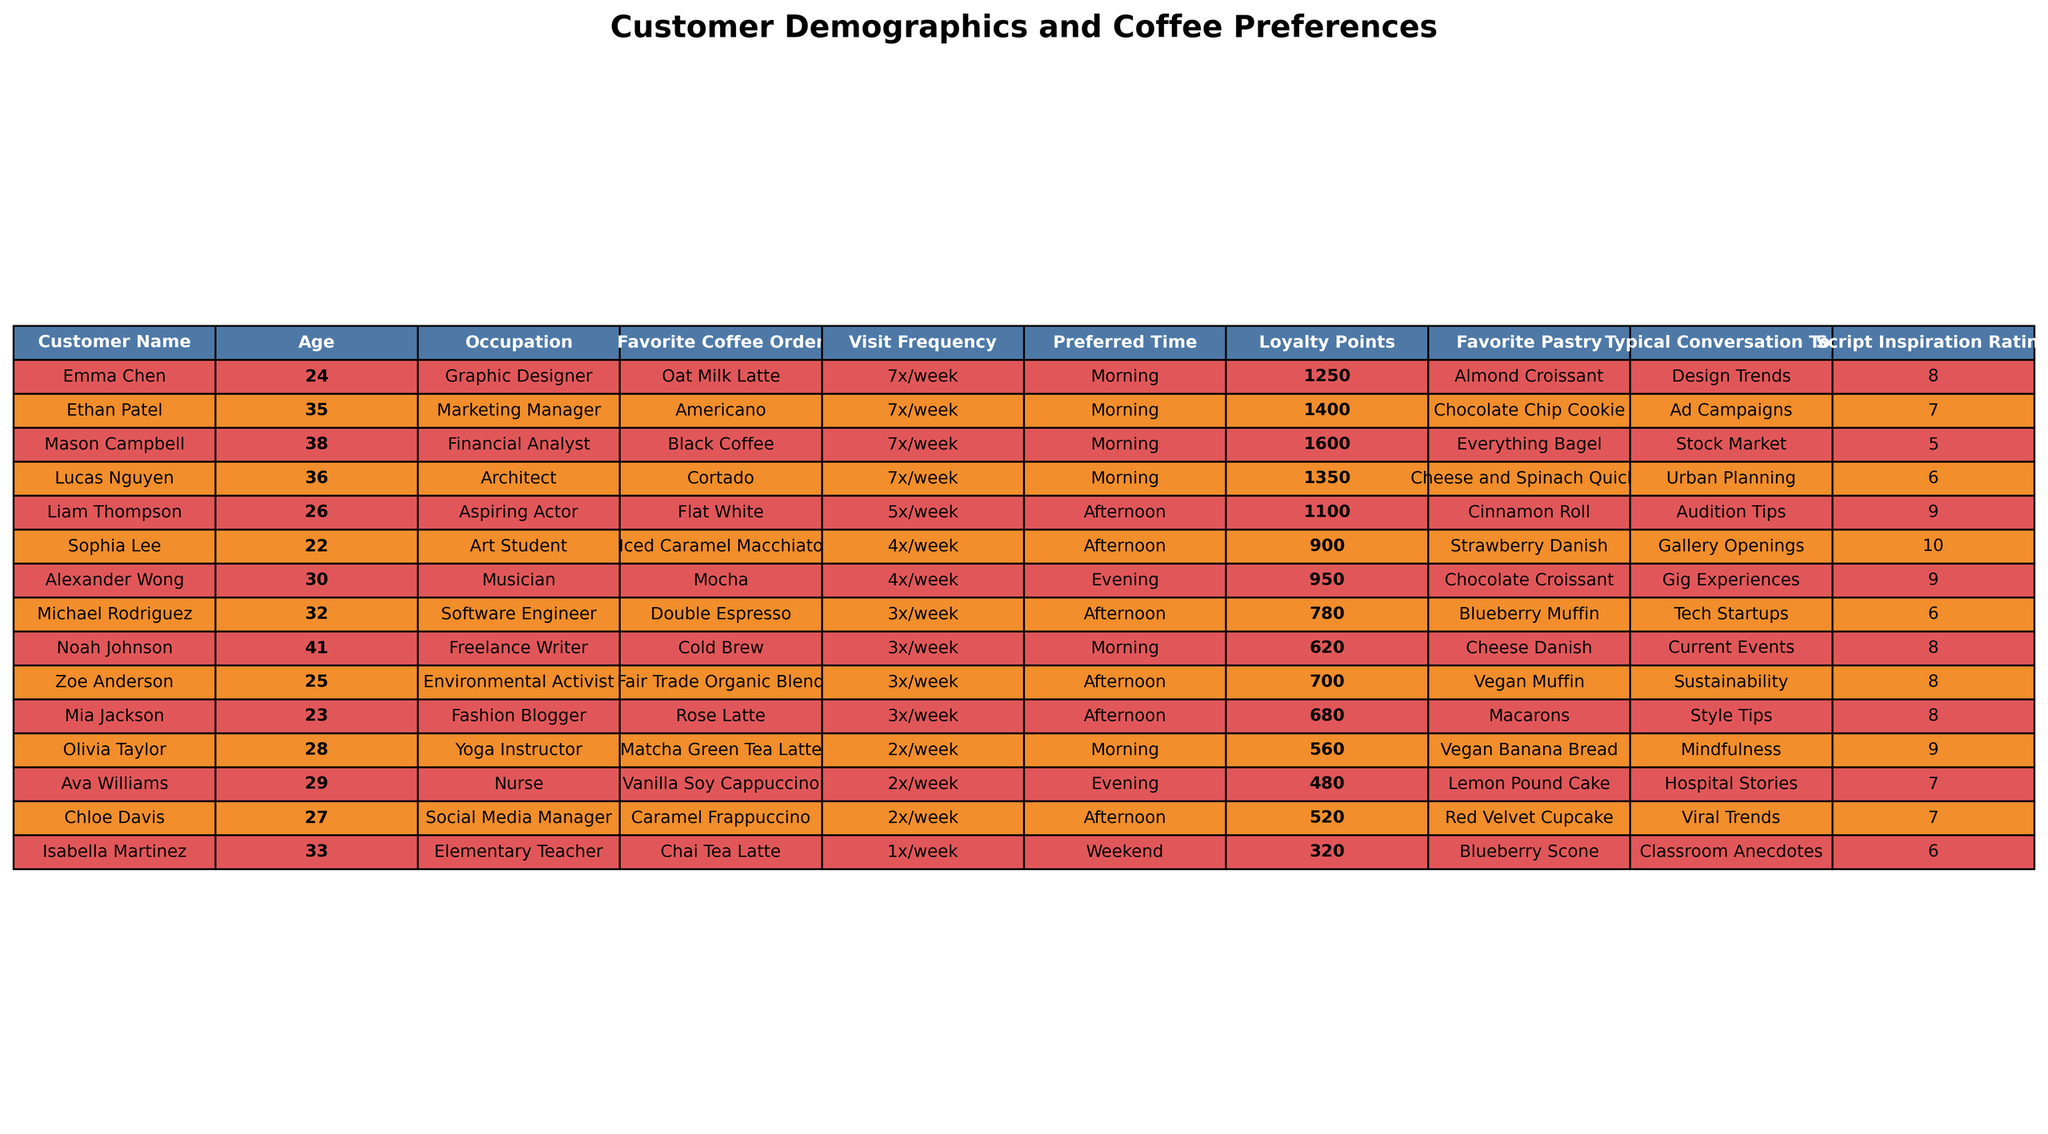What is the favorite coffee order of Michael Rodriguez? The table lists Michael Rodriguez's favorite coffee order in the "Favorite Coffee Order" column, which is "Double Espresso."
Answer: Double Espresso How many loyalty points does Sophia Lee have? Looking at the "Loyalty Points" column for Sophia Lee, the value listed is 900.
Answer: 900 Who has the highest loyalty points? Scanning the "Loyalty Points" column, Mason Campbell has the highest loyalty points at 1600.
Answer: Mason Campbell Is Olivia Taylor a Yoga Instructor? By checking the "Occupation" column for Olivia Taylor, it states "Yoga Instructor," confirming it is true.
Answer: Yes What is the average age of the customers listed in the table? The ages listed are 24, 32, 28, 35, 22, 41, 29, 26, 33, 38, 25, 30, 27, 36, and 23. Summing these ages gives 24 + 32 + 28 + 35 + 22 + 41 + 29 + 26 + 33 + 38 + 25 + 30 + 27 + 36 + 23 = 510. There are 15 customers, so the average age is 510 / 15 = 34.
Answer: 34 What is the favorite pastry of the customer who visits most frequently? Liam Thompson visits 5 times a week, making him one of the most frequent visitors. His favorite pastry is a "Cinnamon Roll."
Answer: Cinnamon Roll Which customer prefers their coffee in the evening? From the "Preferred Time" column, we see that Ava Williams and Alexander Wong both prefer their coffee in the evening.
Answer: Ava Williams, Alexander Wong How many customers prefer a form of latte as their favorite coffee? By counting the occurrences of various latte types in the "Favorite Coffee Order" column, there are 5 customers who prefer a latte (Oat Milk Latte, Vanilla Soy Cappuccino, Iced Caramel Macchiato, Mocha, Rose Latte).
Answer: 5 What is the most common visit frequency among these customers? Looking at the "Visit Frequency" column, "3x/week" appears most frequently, listed for 5 customers.
Answer: 3x/week Which occupation has the highest average Script Inspiration Rating? To find this, we evaluate the Script Inspiration Ratings for each occupation: Graphic Designer (8), Software Engineer (6), Yoga Instructor (9), Marketing Manager (7), Art Student (10), Freelance Writer (8), Nurse (7), Aspiring Actor (9), Elementary Teacher (6), Financial Analyst (5), Musician (9), Social Media Manager (7), Environmental Activist (8), Fashion Blogger (8). The average for occupations with interesting ratings like Art Student and Musician is 9 due to multiple customers scoring 9 or higher.
Answer: Art Student, Musician Is the favorite coffee order of customers in the marketing field the same type? By checking the "Favorite Coffee Order" for Ethan Patel (Americano) and any other marketing-related customers, none other fits this occupation, so the comparison cannot be made.
Answer: No 